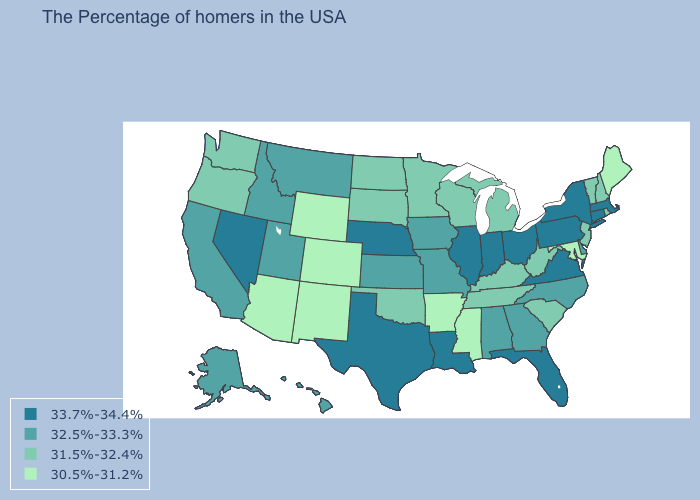Is the legend a continuous bar?
Keep it brief. No. Does Rhode Island have a lower value than Georgia?
Short answer required. Yes. Name the states that have a value in the range 30.5%-31.2%?
Answer briefly. Maine, Maryland, Mississippi, Arkansas, Wyoming, Colorado, New Mexico, Arizona. Name the states that have a value in the range 32.5%-33.3%?
Give a very brief answer. Delaware, North Carolina, Georgia, Alabama, Missouri, Iowa, Kansas, Utah, Montana, Idaho, California, Alaska, Hawaii. Does North Dakota have a lower value than New Jersey?
Keep it brief. No. Name the states that have a value in the range 30.5%-31.2%?
Answer briefly. Maine, Maryland, Mississippi, Arkansas, Wyoming, Colorado, New Mexico, Arizona. What is the highest value in the MidWest ?
Write a very short answer. 33.7%-34.4%. What is the value of Iowa?
Short answer required. 32.5%-33.3%. Name the states that have a value in the range 33.7%-34.4%?
Write a very short answer. Massachusetts, Connecticut, New York, Pennsylvania, Virginia, Ohio, Florida, Indiana, Illinois, Louisiana, Nebraska, Texas, Nevada. What is the value of Alaska?
Quick response, please. 32.5%-33.3%. What is the highest value in states that border Kentucky?
Be succinct. 33.7%-34.4%. Does the first symbol in the legend represent the smallest category?
Answer briefly. No. Among the states that border New Jersey , does Delaware have the highest value?
Short answer required. No. Does Maryland have a lower value than Maine?
Keep it brief. No. Among the states that border New Jersey , which have the highest value?
Quick response, please. New York, Pennsylvania. 